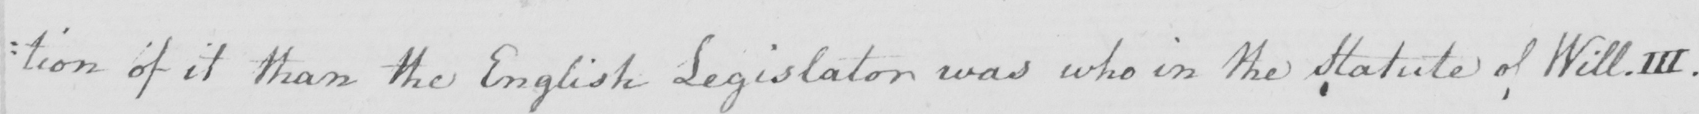What is written in this line of handwriting? : tion of it than the English Legislator was who in the Statute of Will.III . 